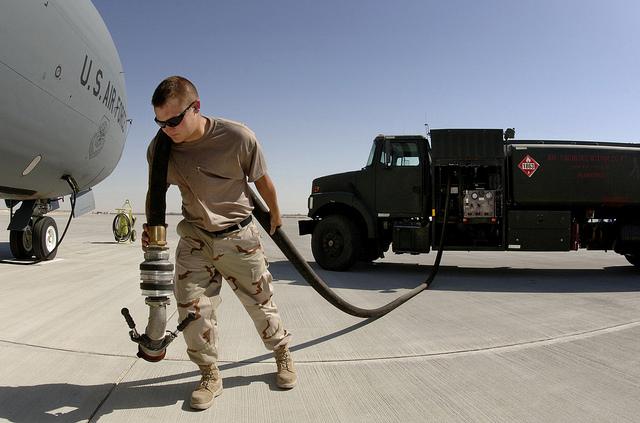Is this a military plane?
Be succinct. Yes. What is the man carrying?
Keep it brief. Hose. What surface is he standing on?
Keep it brief. Concrete. 